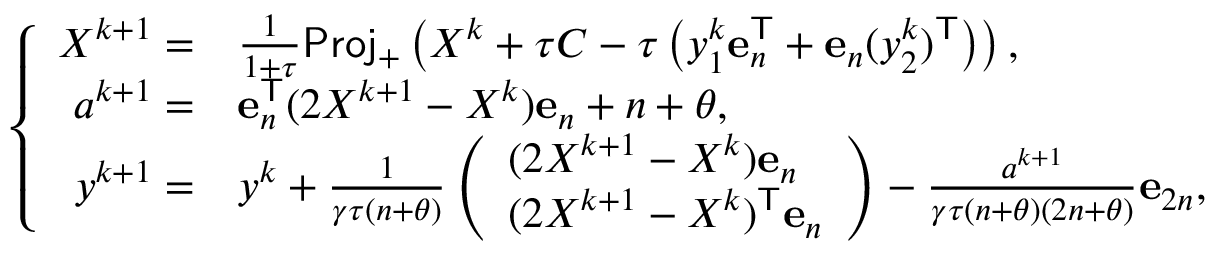<formula> <loc_0><loc_0><loc_500><loc_500>\left \{ \begin{array} { r l } { X ^ { k + 1 } = } & { \frac { 1 } { 1 + \tau } P r o j _ { + } \left ( X ^ { k } + \tau C - \tau \left ( y _ { 1 } ^ { k } e _ { n } ^ { T } + e _ { n } ( y _ { 2 } ^ { k } ) ^ { T } \right ) \right ) , } \\ { a ^ { k + 1 } = } & { e _ { n } ^ { T } ( 2 X ^ { k + 1 } - X ^ { k } ) e _ { n } + n + \theta , } \\ { y ^ { k + 1 } = } & { y ^ { k } + \frac { 1 } { \gamma \tau ( n + \theta ) } \left ( \begin{array} { l } { ( 2 X ^ { k + 1 } - X ^ { k } ) e _ { n } } \\ { ( 2 X ^ { k + 1 } - X ^ { k } ) ^ { T } e _ { n } } \end{array} \right ) - \frac { a ^ { k + 1 } } { \gamma \tau ( n + \theta ) ( 2 n + \theta ) } e _ { 2 n } , } \end{array}</formula> 